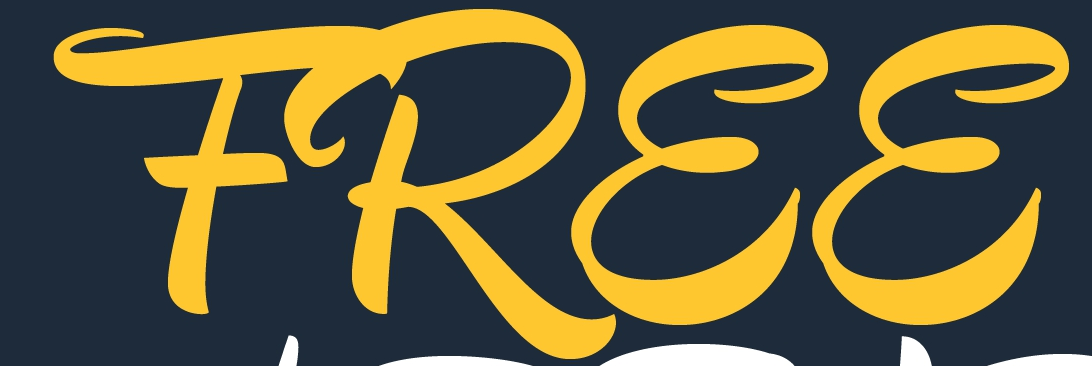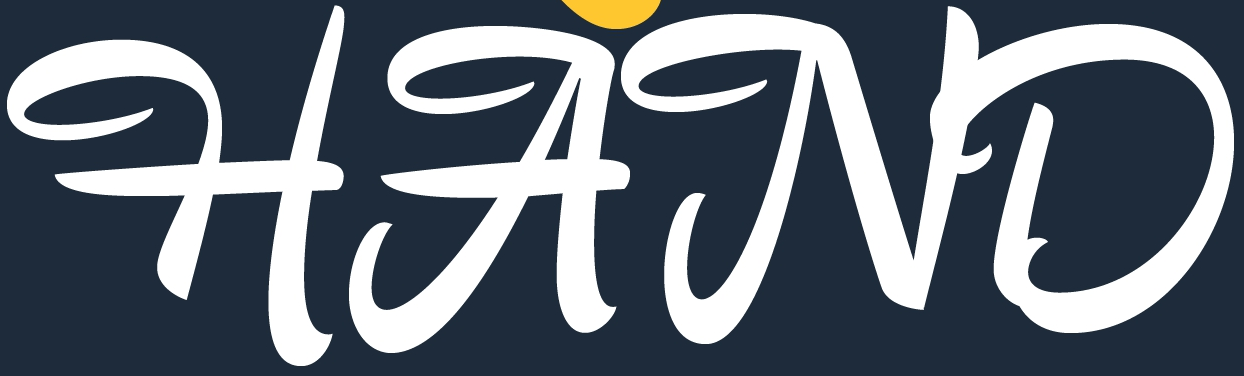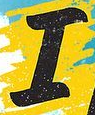Transcribe the words shown in these images in order, separated by a semicolon. FREE; HAND; I 